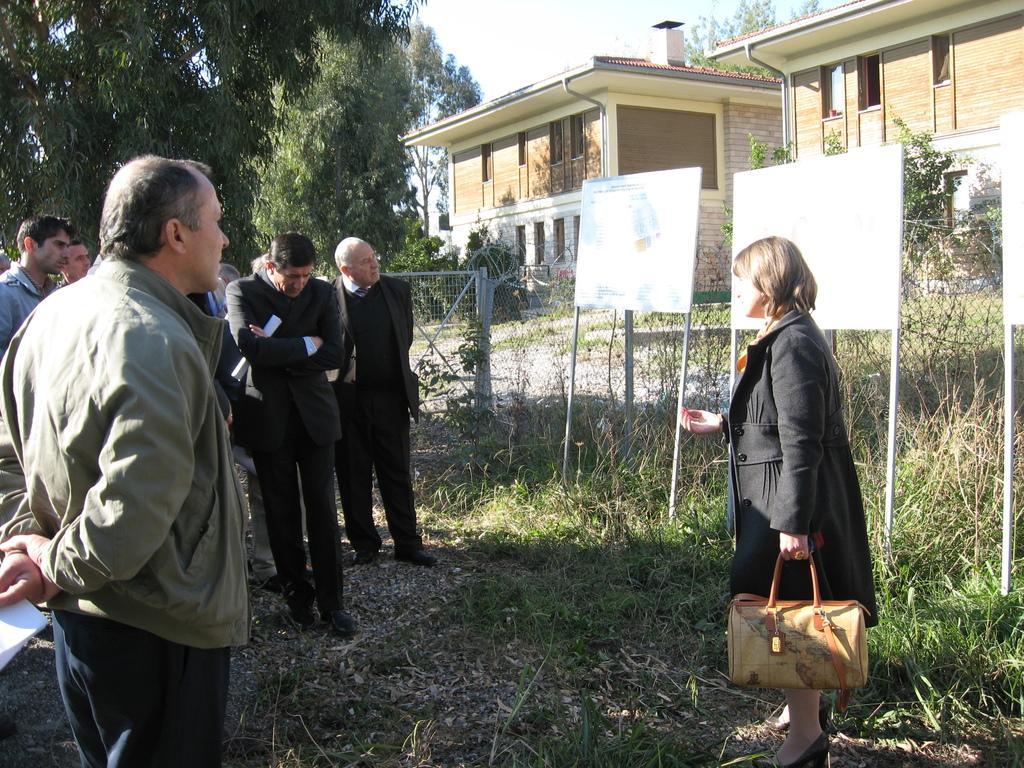Could you give a brief overview of what you see in this image? In this there are group of people listening to a woman. The woman is in coat holding a bag in her hand. They are observing few boards behind her. Some of them are keenly listening at her. There is fencing behind them. At a distance there are trees and two houses which are apart. 